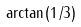Convert formula to latex. <formula><loc_0><loc_0><loc_500><loc_500>\arctan ( 1 / 3 )</formula> 